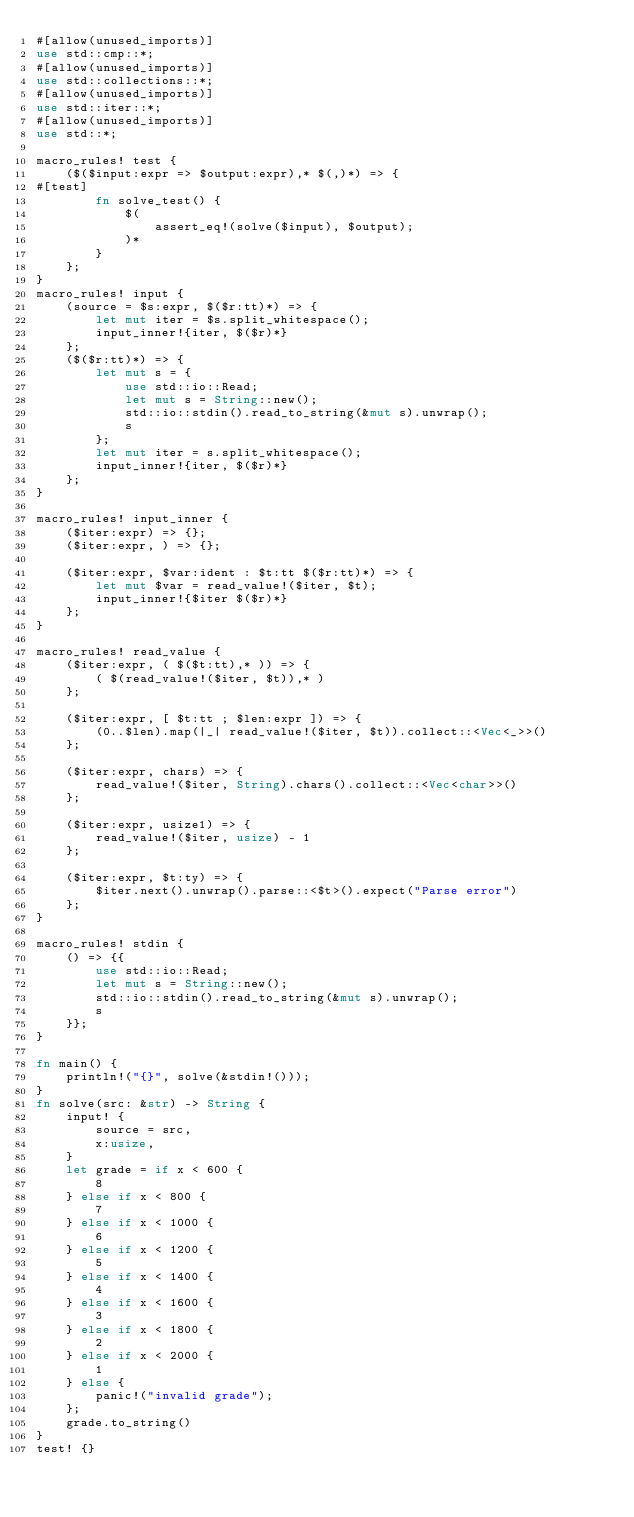<code> <loc_0><loc_0><loc_500><loc_500><_Rust_>#[allow(unused_imports)]
use std::cmp::*;
#[allow(unused_imports)]
use std::collections::*;
#[allow(unused_imports)]
use std::iter::*;
#[allow(unused_imports)]
use std::*;

macro_rules! test {
    ($($input:expr => $output:expr),* $(,)*) => {
#[test]
        fn solve_test() {
            $(
                assert_eq!(solve($input), $output);
            )*
        }
    };
}
macro_rules! input {
    (source = $s:expr, $($r:tt)*) => {
        let mut iter = $s.split_whitespace();
        input_inner!{iter, $($r)*}
    };
    ($($r:tt)*) => {
        let mut s = {
            use std::io::Read;
            let mut s = String::new();
            std::io::stdin().read_to_string(&mut s).unwrap();
            s
        };
        let mut iter = s.split_whitespace();
        input_inner!{iter, $($r)*}
    };
}

macro_rules! input_inner {
    ($iter:expr) => {};
    ($iter:expr, ) => {};

    ($iter:expr, $var:ident : $t:tt $($r:tt)*) => {
        let mut $var = read_value!($iter, $t);
        input_inner!{$iter $($r)*}
    };
}

macro_rules! read_value {
    ($iter:expr, ( $($t:tt),* )) => {
        ( $(read_value!($iter, $t)),* )
    };

    ($iter:expr, [ $t:tt ; $len:expr ]) => {
        (0..$len).map(|_| read_value!($iter, $t)).collect::<Vec<_>>()
    };

    ($iter:expr, chars) => {
        read_value!($iter, String).chars().collect::<Vec<char>>()
    };

    ($iter:expr, usize1) => {
        read_value!($iter, usize) - 1
    };

    ($iter:expr, $t:ty) => {
        $iter.next().unwrap().parse::<$t>().expect("Parse error")
    };
}

macro_rules! stdin {
    () => {{
        use std::io::Read;
        let mut s = String::new();
        std::io::stdin().read_to_string(&mut s).unwrap();
        s
    }};
}

fn main() {
    println!("{}", solve(&stdin!()));
}
fn solve(src: &str) -> String {
    input! {
        source = src,
        x:usize,
    }
    let grade = if x < 600 {
        8
    } else if x < 800 {
        7
    } else if x < 1000 {
        6
    } else if x < 1200 {
        5
    } else if x < 1400 {
        4
    } else if x < 1600 {
        3
    } else if x < 1800 {
        2
    } else if x < 2000 {
        1
    } else {
        panic!("invalid grade");
    };
    grade.to_string()
}
test! {}
</code> 